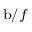<formula> <loc_0><loc_0><loc_500><loc_500>_ { b / f }</formula> 